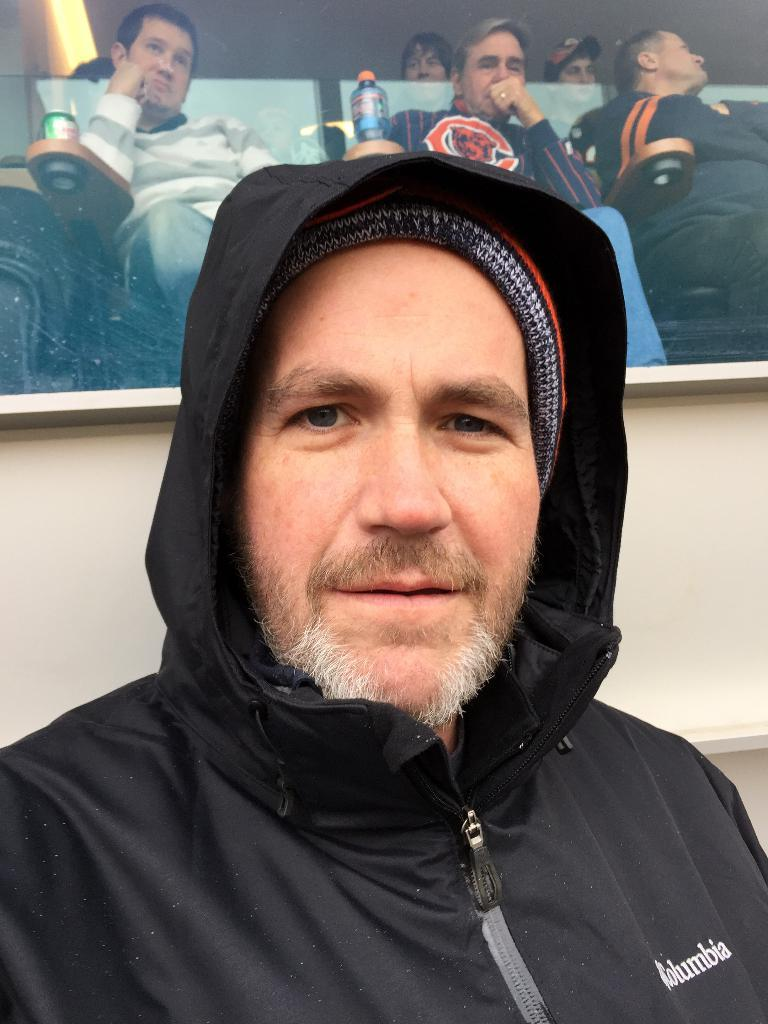Who is the main subject in the foreground of the image? There is a man in the foreground of the image. What is the man wearing in the image? The man is wearing a black overcoat. What can be seen in the background of the image? In the background, there are people sitting on chairs. What type of silk is being used to make the money in the image? There is no silk or money present in the image. How many men are visible in the image? The image only shows one man in the foreground, so there is only one man visible. 